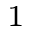<formula> <loc_0><loc_0><loc_500><loc_500>_ { 1 }</formula> 